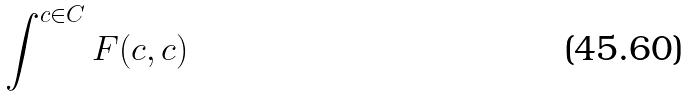<formula> <loc_0><loc_0><loc_500><loc_500>\int ^ { c \in C } F ( c , c )</formula> 